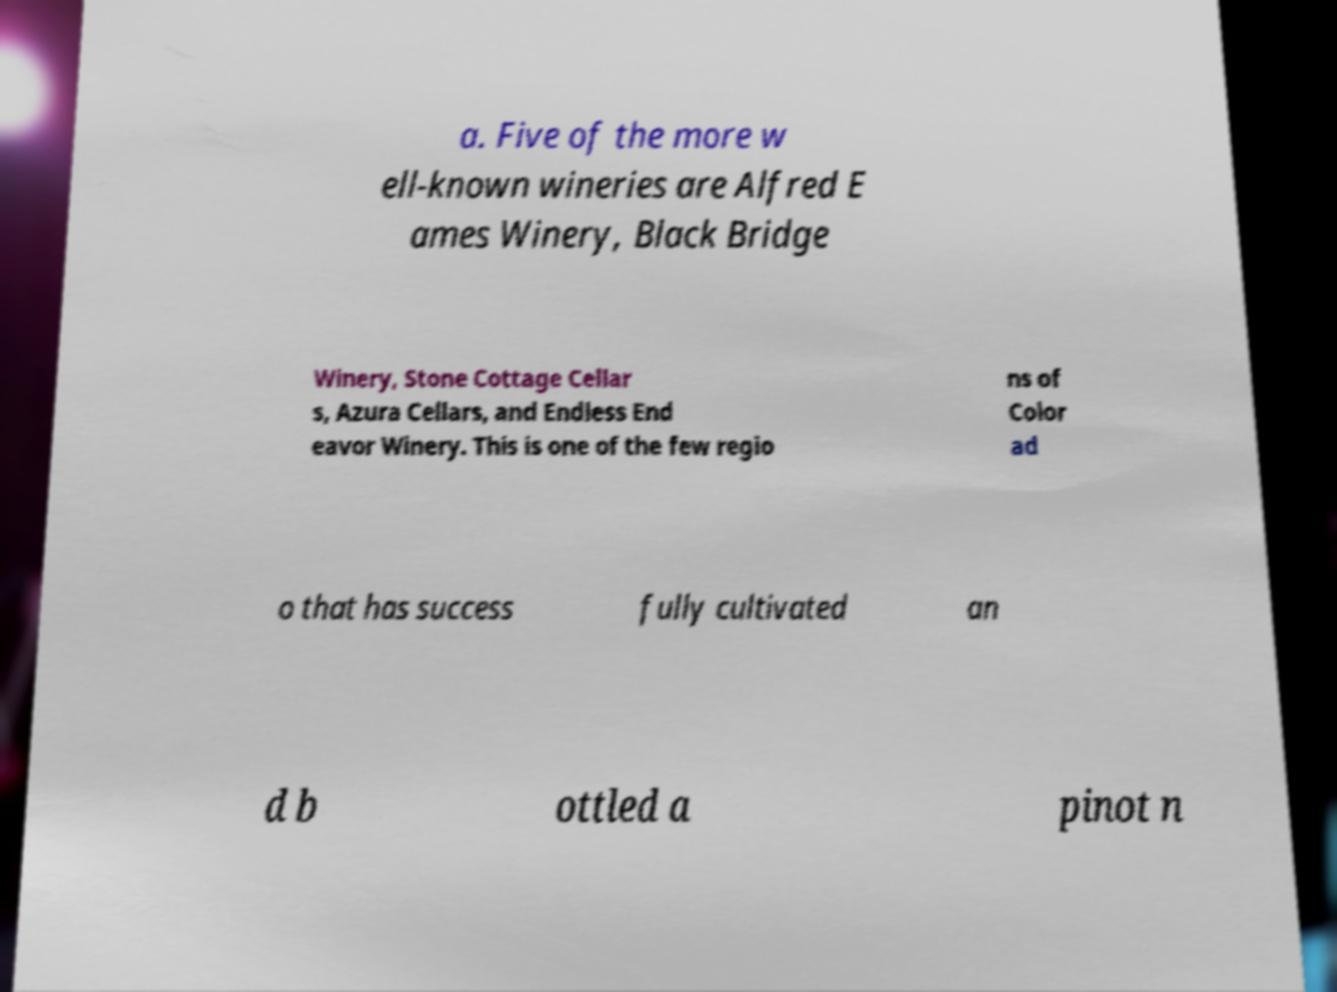I need the written content from this picture converted into text. Can you do that? a. Five of the more w ell-known wineries are Alfred E ames Winery, Black Bridge Winery, Stone Cottage Cellar s, Azura Cellars, and Endless End eavor Winery. This is one of the few regio ns of Color ad o that has success fully cultivated an d b ottled a pinot n 